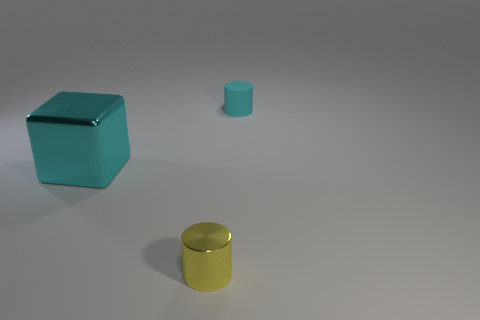Is there any other thing that has the same material as the small cyan cylinder?
Your answer should be very brief. No. There is a thing that is on the left side of the small matte object and behind the small shiny cylinder; how big is it?
Offer a very short reply. Large. Are the tiny yellow cylinder and the cyan thing on the left side of the yellow thing made of the same material?
Provide a succinct answer. Yes. How many other cyan objects have the same shape as the tiny rubber object?
Ensure brevity in your answer.  0. There is a thing that is the same color as the rubber cylinder; what material is it?
Provide a succinct answer. Metal. How many cyan cubes are there?
Your response must be concise. 1. There is a rubber object; does it have the same shape as the shiny thing on the left side of the small yellow cylinder?
Offer a very short reply. No. What number of objects are either cyan things or big things that are in front of the small matte object?
Keep it short and to the point. 2. What material is the other thing that is the same shape as the tiny cyan thing?
Make the answer very short. Metal. Do the cyan thing left of the rubber cylinder and the cyan rubber thing have the same shape?
Your response must be concise. No. 